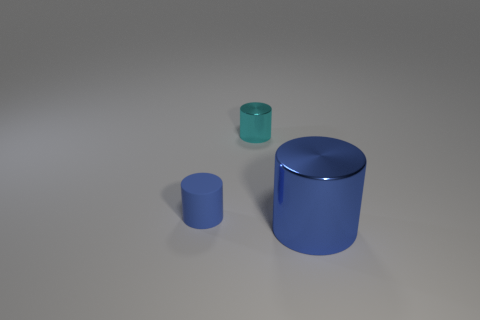The tiny shiny cylinder is what color?
Offer a very short reply. Cyan. Is there any other thing that is the same material as the tiny blue cylinder?
Ensure brevity in your answer.  No. What shape is the object that is left of the cyan cylinder?
Offer a very short reply. Cylinder. There is a blue cylinder that is behind the shiny object that is to the right of the tiny metallic cylinder; are there any cyan metallic objects in front of it?
Offer a very short reply. No. Are any tiny gray rubber things visible?
Your answer should be compact. No. Does the blue cylinder behind the blue metal object have the same material as the blue object to the right of the tiny cyan cylinder?
Give a very brief answer. No. There is a blue shiny cylinder in front of the object that is on the left side of the tiny metal object on the left side of the big blue metallic cylinder; how big is it?
Offer a very short reply. Large. How many cylinders have the same material as the tiny blue thing?
Give a very brief answer. 0. Are there fewer blue cylinders than big blue rubber cylinders?
Your answer should be very brief. No. The other metal object that is the same shape as the large blue metal object is what size?
Ensure brevity in your answer.  Small. 